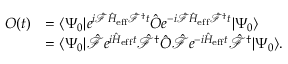Convert formula to latex. <formula><loc_0><loc_0><loc_500><loc_500>\begin{array} { r l } { O ( t ) } & { = \langle \Psi _ { 0 } | e ^ { i \hat { \mathcal { F } } \hat { H } _ { e f f } \hat { \mathcal { F } } ^ { \dagger } t } \hat { O } e ^ { - i \hat { \mathcal { F } } \hat { H } _ { e f f } \hat { \mathcal { F } } ^ { \dagger } t } | \Psi _ { 0 } \rangle } \\ & { = \langle \Psi _ { 0 } | \hat { \mathcal { F } } e ^ { i \hat { H } _ { e f f } t } \hat { \mathcal { F } } ^ { \dagger } \hat { O } \hat { \mathcal { F } } e ^ { - i \hat { H } _ { e f f } t } \hat { \mathcal { F } } ^ { \dagger } | \Psi _ { 0 } \rangle . } \end{array}</formula> 